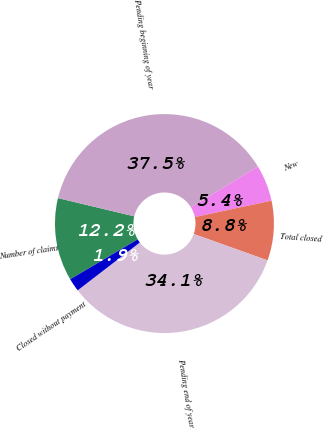Convert chart. <chart><loc_0><loc_0><loc_500><loc_500><pie_chart><fcel>Number of claims<fcel>Pending beginning of year<fcel>New<fcel>Total closed<fcel>Pending end of year<fcel>Closed without payment<nl><fcel>12.24%<fcel>37.54%<fcel>5.37%<fcel>8.81%<fcel>34.1%<fcel>1.94%<nl></chart> 